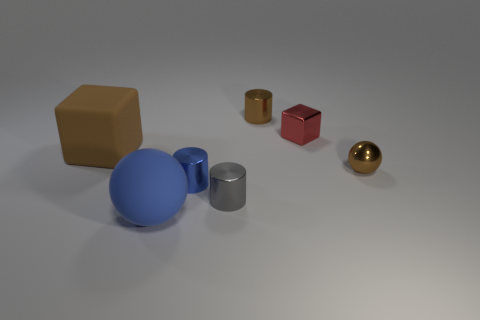Is the number of blue cubes greater than the number of large rubber cubes?
Keep it short and to the point. No. What number of other things are the same shape as the large blue matte thing?
Your response must be concise. 1. Is the color of the rubber cube the same as the matte ball?
Ensure brevity in your answer.  No. What is the object that is on the left side of the tiny blue metal cylinder and behind the blue rubber thing made of?
Make the answer very short. Rubber. How big is the gray shiny thing?
Offer a very short reply. Small. What number of brown cylinders are to the right of the tiny brown metal object to the right of the small brown thing behind the small ball?
Provide a short and direct response. 0. There is a big thing that is in front of the block that is on the left side of the small brown shiny cylinder; what is its shape?
Your answer should be compact. Sphere. What is the size of the gray metallic object that is the same shape as the small blue thing?
Give a very brief answer. Small. Is there any other thing that is the same size as the red object?
Provide a short and direct response. Yes. There is a big object behind the tiny ball; what is its color?
Your answer should be compact. Brown. 